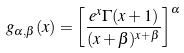Convert formula to latex. <formula><loc_0><loc_0><loc_500><loc_500>g _ { \alpha , \beta } ( x ) = \left [ \frac { e ^ { x } \Gamma ( x + 1 ) } { ( x + \beta ) ^ { x + \beta } } \right ] ^ { \alpha }</formula> 